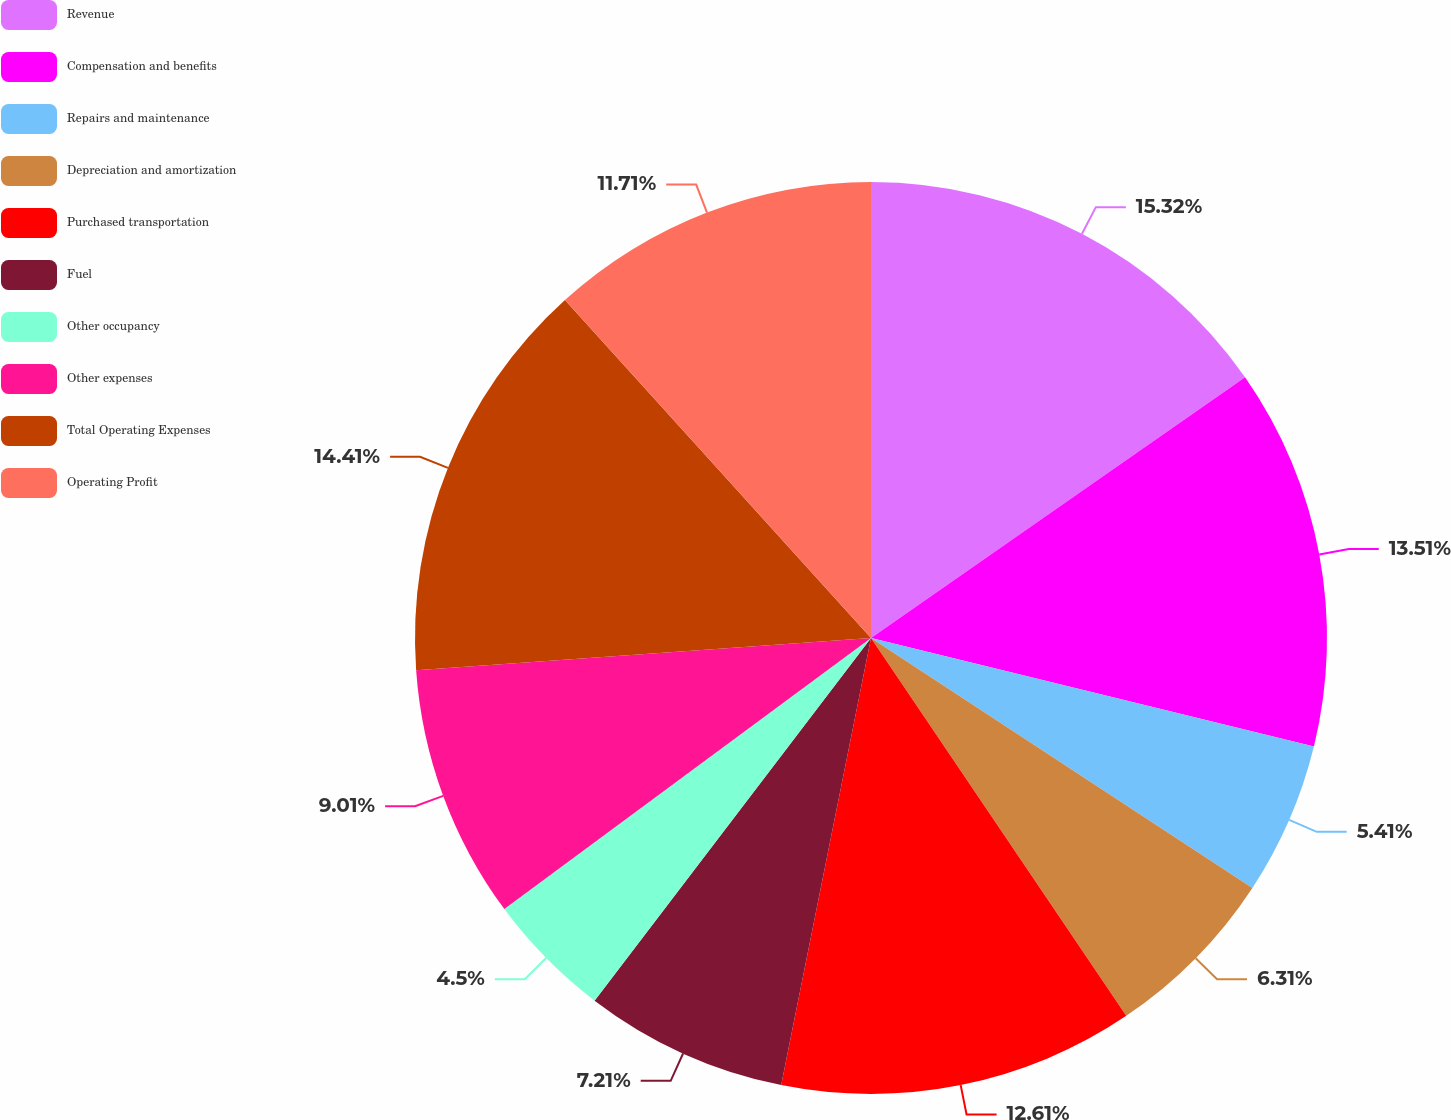Convert chart. <chart><loc_0><loc_0><loc_500><loc_500><pie_chart><fcel>Revenue<fcel>Compensation and benefits<fcel>Repairs and maintenance<fcel>Depreciation and amortization<fcel>Purchased transportation<fcel>Fuel<fcel>Other occupancy<fcel>Other expenses<fcel>Total Operating Expenses<fcel>Operating Profit<nl><fcel>15.31%<fcel>13.51%<fcel>5.41%<fcel>6.31%<fcel>12.61%<fcel>7.21%<fcel>4.5%<fcel>9.01%<fcel>14.41%<fcel>11.71%<nl></chart> 